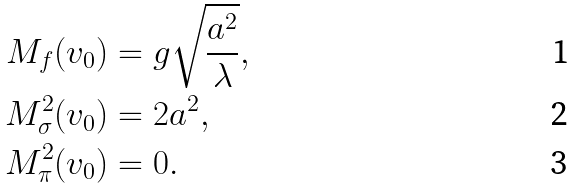Convert formula to latex. <formula><loc_0><loc_0><loc_500><loc_500>M _ { f } ( v _ { 0 } ) & = g \sqrt { \frac { a ^ { 2 } } { \lambda } } , \\ M _ { \sigma } ^ { 2 } ( v _ { 0 } ) & = 2 a ^ { 2 } , \\ M _ { \pi } ^ { 2 } ( v _ { 0 } ) & = 0 .</formula> 